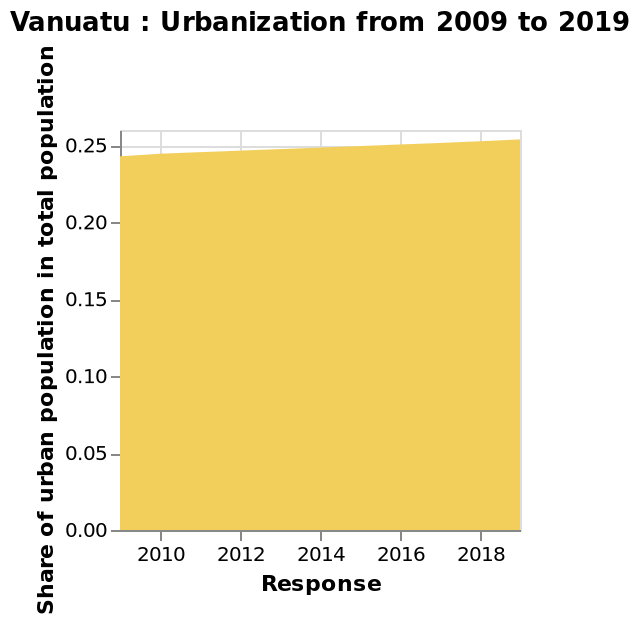<image>
please describe the details of the chart Vanuatu : Urbanization from 2009 to 2019 is a area graph. The x-axis plots Response while the y-axis shows Share of urban population in total population. What is the rate of increase in the share of urban population in Vanuatu? The rate of increase in the share of urban population in Vanuatu is not specified in the given information. 